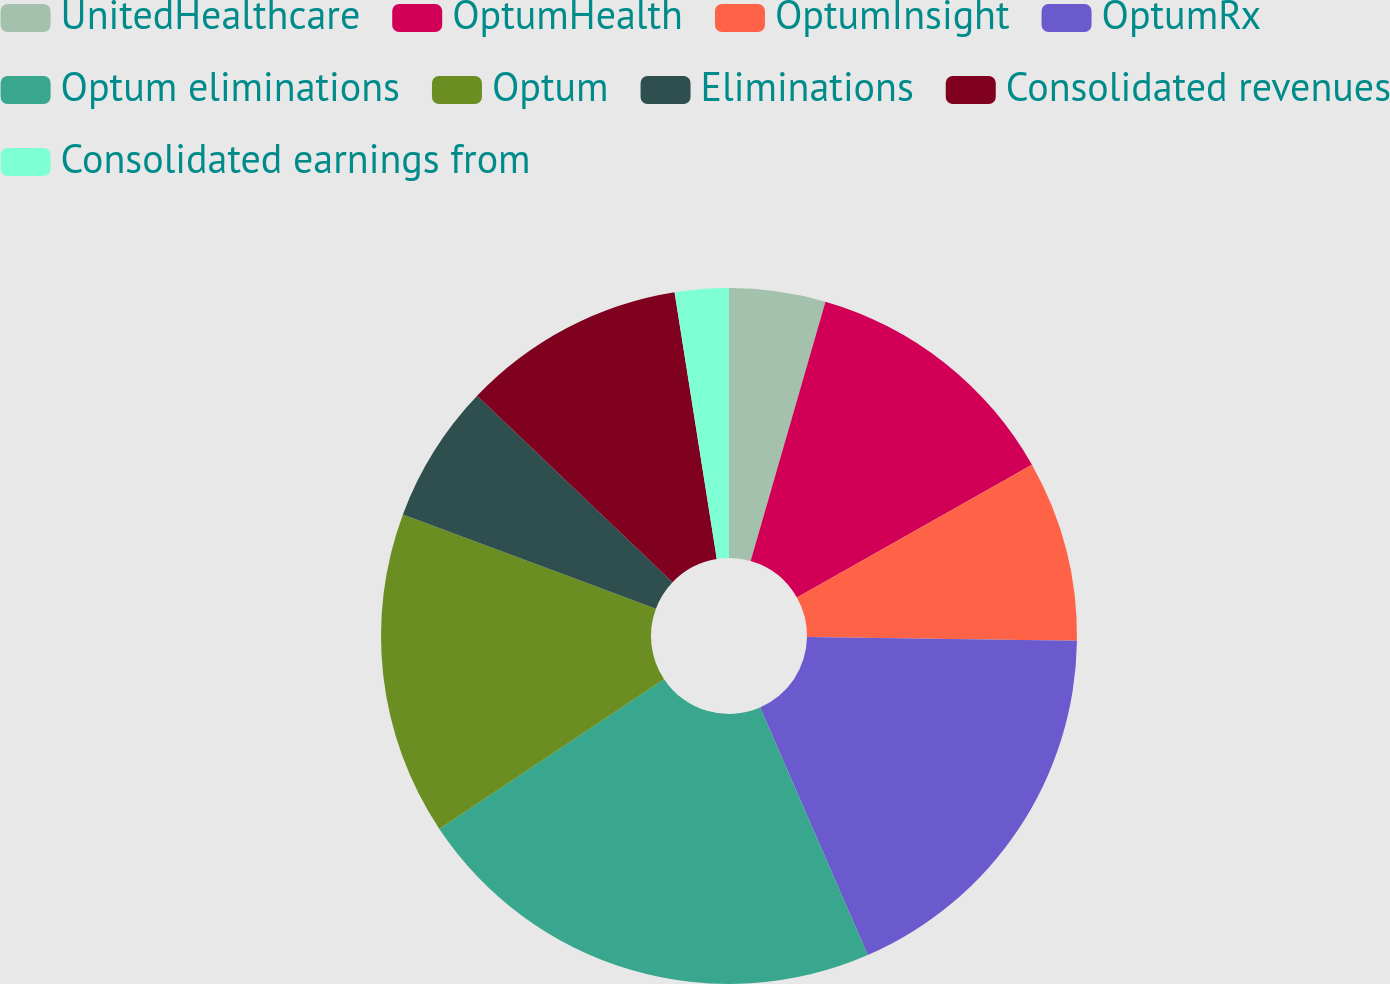Convert chart. <chart><loc_0><loc_0><loc_500><loc_500><pie_chart><fcel>UnitedHealthcare<fcel>OptumHealth<fcel>OptumInsight<fcel>OptumRx<fcel>Optum eliminations<fcel>Optum<fcel>Eliminations<fcel>Consolidated revenues<fcel>Consolidated earnings from<nl><fcel>4.47%<fcel>12.34%<fcel>8.41%<fcel>18.25%<fcel>22.18%<fcel>15.03%<fcel>6.44%<fcel>10.38%<fcel>2.5%<nl></chart> 